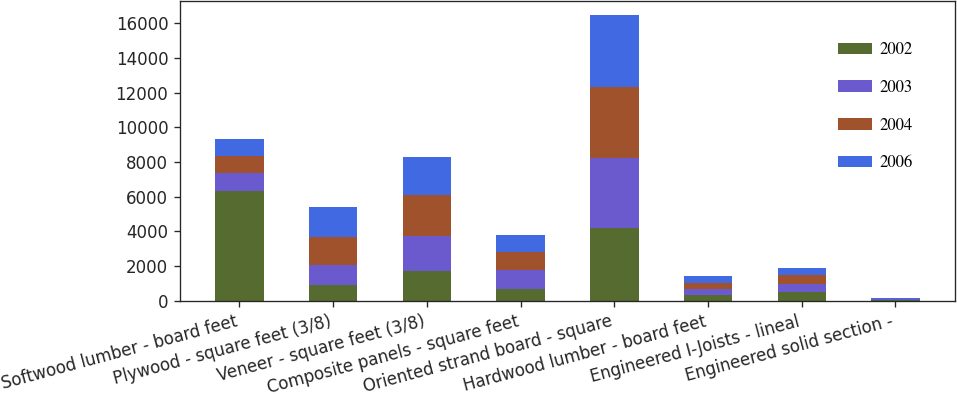<chart> <loc_0><loc_0><loc_500><loc_500><stacked_bar_chart><ecel><fcel>Softwood lumber - board feet<fcel>Plywood - square feet (3/8)<fcel>Veneer - square feet (3/8)<fcel>Composite panels - square feet<fcel>Oriented strand board - square<fcel>Hardwood lumber - board feet<fcel>Engineered I-Joists - lineal<fcel>Engineered solid section -<nl><fcel>2002<fcel>6355<fcel>900<fcel>1739<fcel>666<fcel>4166<fcel>324<fcel>473<fcel>41<nl><fcel>2003<fcel>988<fcel>1155<fcel>1979<fcel>1080<fcel>4078<fcel>364<fcel>483<fcel>41<nl><fcel>2004<fcel>988<fcel>1628<fcel>2386<fcel>1066<fcel>4081<fcel>349<fcel>504<fcel>42<nl><fcel>2006<fcel>988<fcel>1708<fcel>2199<fcel>988<fcel>4170<fcel>373<fcel>437<fcel>34<nl></chart> 